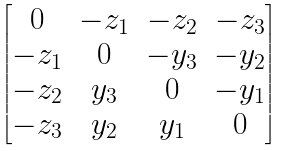Convert formula to latex. <formula><loc_0><loc_0><loc_500><loc_500>\begin{bmatrix} 0 & - z _ { 1 } & - z _ { 2 } & - z _ { 3 } \\ - z _ { 1 } & 0 & - y _ { 3 } & - y _ { 2 } \\ - z _ { 2 } & y _ { 3 } & 0 & - y _ { 1 } \\ - z _ { 3 } & y _ { 2 } & y _ { 1 } & 0 \end{bmatrix}</formula> 